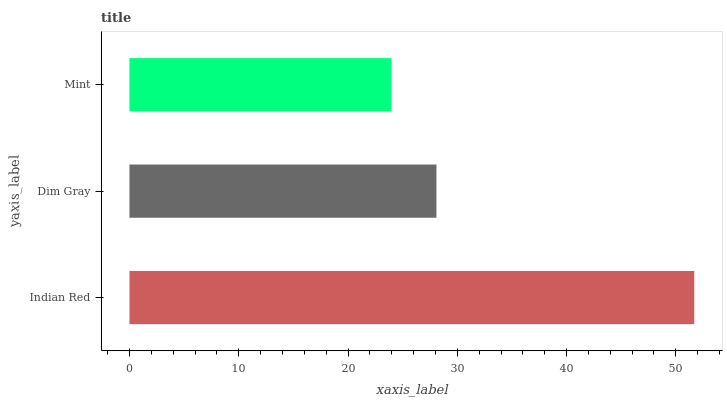Is Mint the minimum?
Answer yes or no. Yes. Is Indian Red the maximum?
Answer yes or no. Yes. Is Dim Gray the minimum?
Answer yes or no. No. Is Dim Gray the maximum?
Answer yes or no. No. Is Indian Red greater than Dim Gray?
Answer yes or no. Yes. Is Dim Gray less than Indian Red?
Answer yes or no. Yes. Is Dim Gray greater than Indian Red?
Answer yes or no. No. Is Indian Red less than Dim Gray?
Answer yes or no. No. Is Dim Gray the high median?
Answer yes or no. Yes. Is Dim Gray the low median?
Answer yes or no. Yes. Is Mint the high median?
Answer yes or no. No. Is Mint the low median?
Answer yes or no. No. 